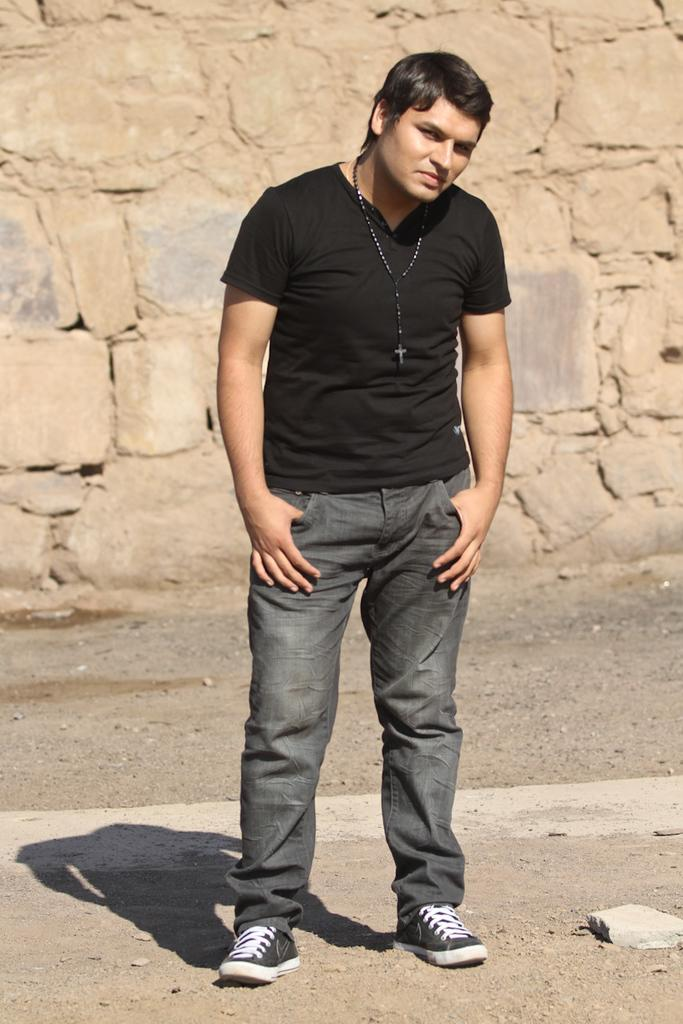Who or what is present in the image? There is a person in the image. What is the person wearing? The person is wearing a rosary. What can be seen in the background of the image? There is a wall in the background of the image. Can you tell me how many dogs are present in the image? There are no dogs present in the image; it features a person wearing a rosary with a wall in the background. 